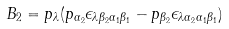<formula> <loc_0><loc_0><loc_500><loc_500>B _ { 2 } = p _ { \lambda } ( p _ { \alpha _ { 2 } } \epsilon _ { \lambda \beta _ { 2 } \alpha _ { 1 } \beta _ { 1 } } - p _ { \beta _ { 2 } } \epsilon _ { \lambda \alpha _ { 2 } \alpha _ { 1 } \beta _ { 1 } } )</formula> 